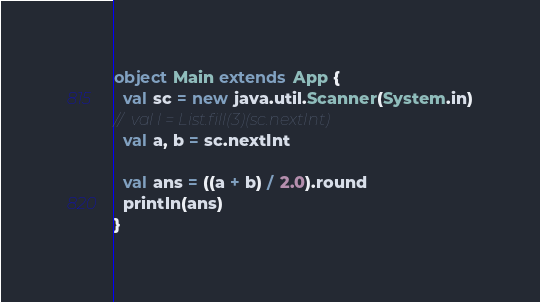Convert code to text. <code><loc_0><loc_0><loc_500><loc_500><_Scala_>object Main extends App {
  val sc = new java.util.Scanner(System.in)
//  val l = List.fill(3)(sc.nextInt)
  val a, b = sc.nextInt

  val ans = ((a + b) / 2.0).round
  println(ans)
}</code> 